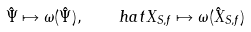Convert formula to latex. <formula><loc_0><loc_0><loc_500><loc_500>\hat { \Psi } \mapsto \omega ( \hat { \Psi } ) , \quad h a t { X } _ { S , f } \mapsto \omega ( \hat { X } _ { S , f } )</formula> 